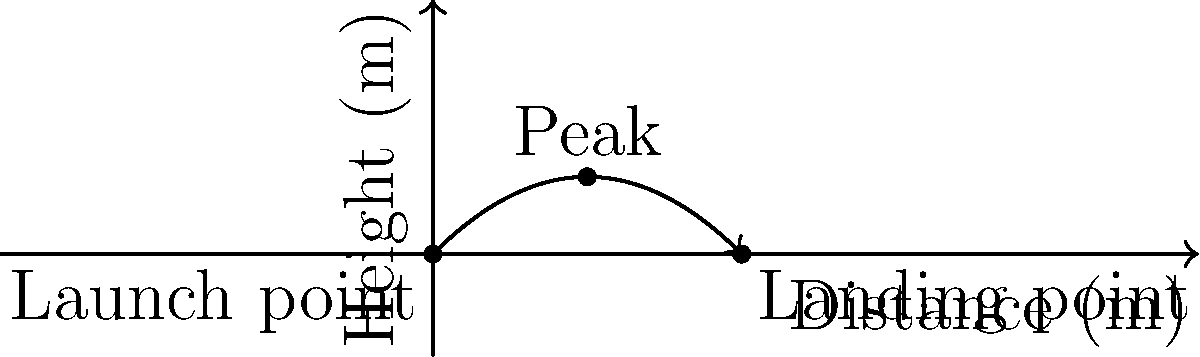In an action scene, a stunt performer needs to jump from one building to another. The initial velocity of the jump is 20 m/s at a 45-degree angle from the horizontal. Assuming no air resistance, what is the total horizontal distance covered by the performer before landing? To solve this problem, we'll use the equations of motion for projectile motion:

1. The horizontal distance: $x = v_0 \cos(\theta) \cdot t$
2. The vertical distance: $y = v_0 \sin(\theta) \cdot t - \frac{1}{2}gt^2$

Where:
$v_0 = 20$ m/s (initial velocity)
$\theta = 45°$ (launch angle)
$g = 9.8$ m/s² (acceleration due to gravity)

Steps:
1. Calculate the time of flight:
   At the landing point, y = 0. So:
   $0 = v_0 \sin(\theta) \cdot t - \frac{1}{2}gt^2$
   $\frac{1}{2}gt^2 = v_0 \sin(\theta) \cdot t$
   $t = \frac{2v_0 \sin(\theta)}{g} = \frac{2 \cdot 20 \cdot \sin(45°)}{9.8} \approx 2.89$ seconds

2. Calculate the horizontal distance:
   $x = v_0 \cos(\theta) \cdot t$
   $x = 20 \cdot \cos(45°) \cdot 2.89$
   $x = 20 \cdot \frac{\sqrt{2}}{2} \cdot 2.89 \approx 40.82$ meters

Therefore, the total horizontal distance covered by the performer is approximately 40.82 meters.
Answer: 40.82 meters 